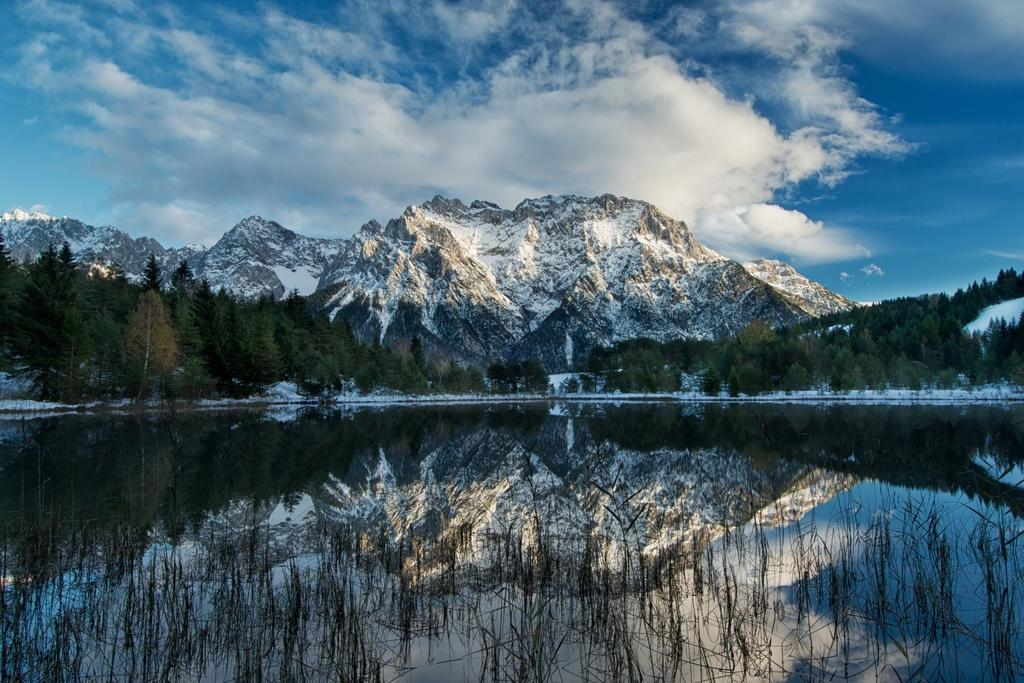What is the primary element visible in the image? There is water in the image. What can be seen in the distance behind the water? There are trees in the background of the image. What is the condition of the mountains in the image? There is snow on the mountains in the image. What part of the natural environment is visible in the image? The sky is visible in the image. How many pizzas are being served at the spring event in the image? There are no pizzas or spring events present in the image. How many houses can be seen in the image? There is no information about houses in the image; it primarily features water, trees, mountains, and the sky. 